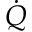Convert formula to latex. <formula><loc_0><loc_0><loc_500><loc_500>\dot { Q }</formula> 